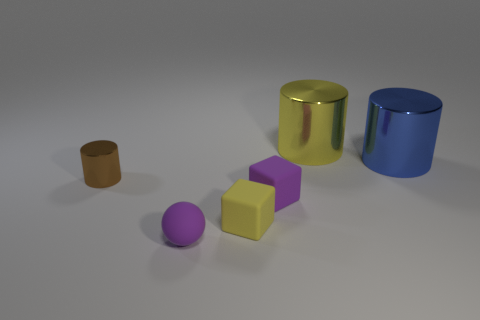Add 1 small yellow rubber cubes. How many objects exist? 7 Subtract all cubes. How many objects are left? 4 Add 5 purple spheres. How many purple spheres are left? 6 Add 6 rubber balls. How many rubber balls exist? 7 Subtract 0 blue cubes. How many objects are left? 6 Subtract all brown cylinders. Subtract all yellow cubes. How many objects are left? 4 